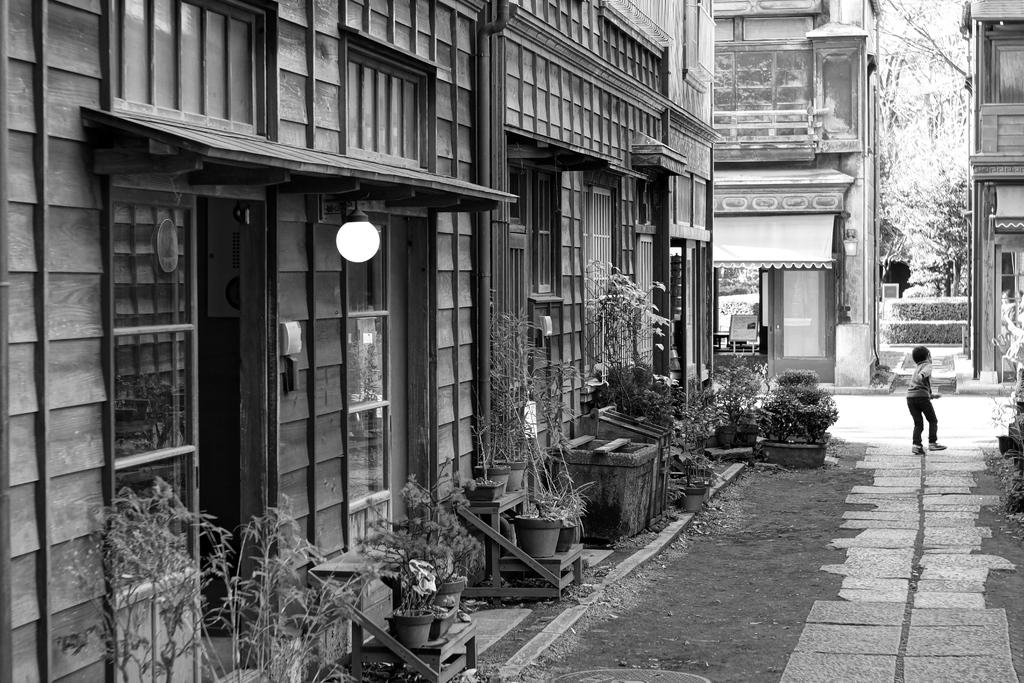What type of structure is illuminated in the image? There is a building with lights in the image. What can be seen near the building? There are plant pots outside the building. What is the boy in the image doing? There is a boy running on the road in the image. What can be seen in the distance along the road? There are other buildings visible in front of the road. Is the boy wearing a crown while running in the image? There is no crown visible in the image, and the boy is not wearing one. 